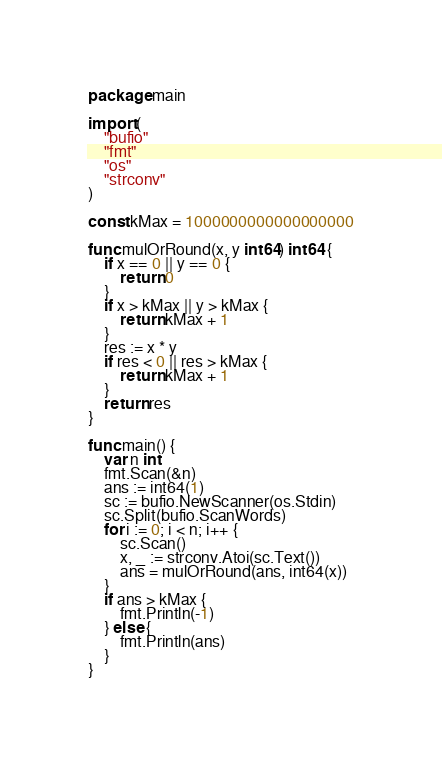Convert code to text. <code><loc_0><loc_0><loc_500><loc_500><_Go_>package main

import (
	"bufio"
	"fmt"
	"os"
	"strconv"
)

const kMax = 1000000000000000000

func mulOrRound(x, y int64) int64 {
	if x == 0 || y == 0 {
		return 0
	}
	if x > kMax || y > kMax {
		return kMax + 1
	}
	res := x * y
	if res < 0 || res > kMax {
		return kMax + 1
	}
	return res
}

func main() {
	var n int
	fmt.Scan(&n)
	ans := int64(1)
	sc := bufio.NewScanner(os.Stdin)
	sc.Split(bufio.ScanWords)
	for i := 0; i < n; i++ {
		sc.Scan()
		x, _ := strconv.Atoi(sc.Text())
		ans = mulOrRound(ans, int64(x))
	}
	if ans > kMax {
		fmt.Println(-1)
	} else {
		fmt.Println(ans)
	}
}
</code> 